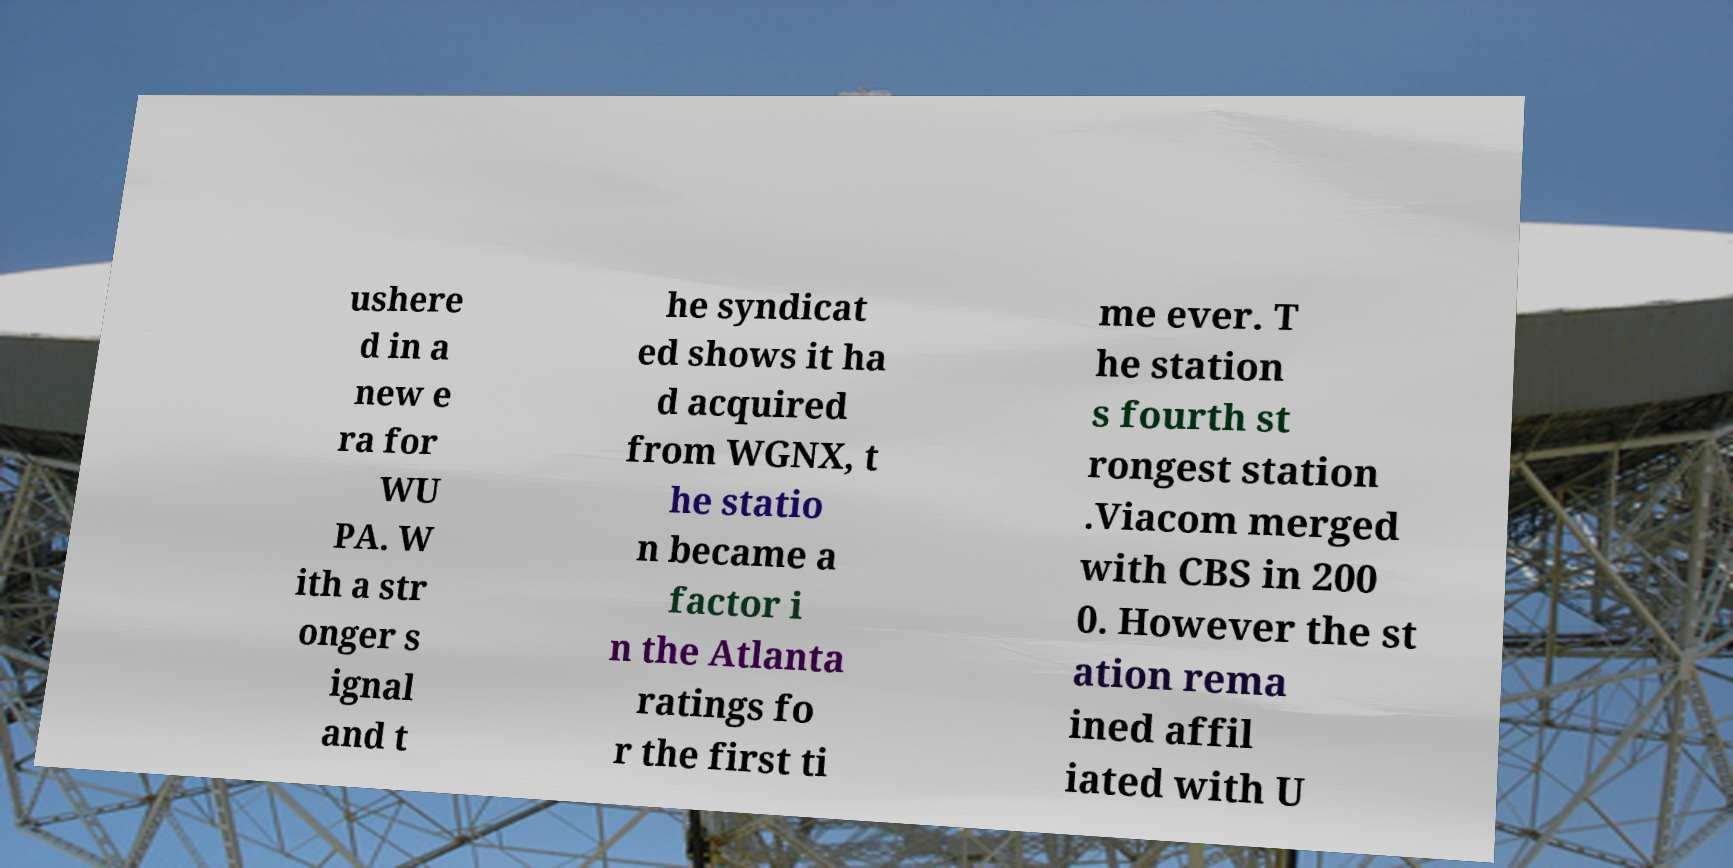What messages or text are displayed in this image? I need them in a readable, typed format. ushere d in a new e ra for WU PA. W ith a str onger s ignal and t he syndicat ed shows it ha d acquired from WGNX, t he statio n became a factor i n the Atlanta ratings fo r the first ti me ever. T he station s fourth st rongest station .Viacom merged with CBS in 200 0. However the st ation rema ined affil iated with U 